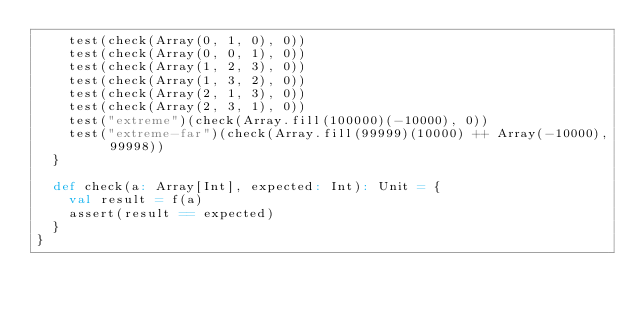Convert code to text. <code><loc_0><loc_0><loc_500><loc_500><_Scala_>    test(check(Array(0, 1, 0), 0))
    test(check(Array(0, 0, 1), 0))
    test(check(Array(1, 2, 3), 0))
    test(check(Array(1, 3, 2), 0))
    test(check(Array(2, 1, 3), 0))
    test(check(Array(2, 3, 1), 0))
    test("extreme")(check(Array.fill(100000)(-10000), 0))
    test("extreme-far")(check(Array.fill(99999)(10000) ++ Array(-10000), 99998))
  }

  def check(a: Array[Int], expected: Int): Unit = {
    val result = f(a)
    assert(result == expected)
  }
}
</code> 